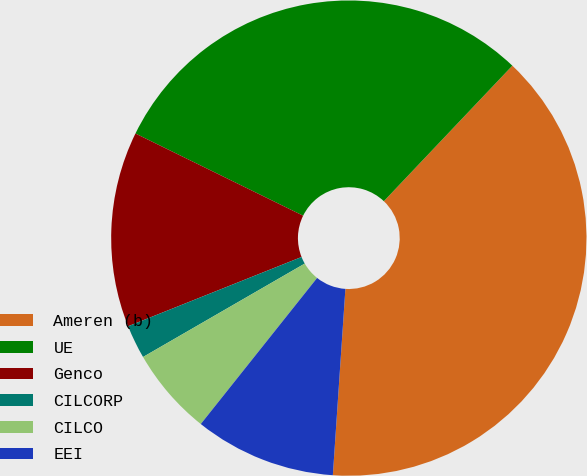<chart> <loc_0><loc_0><loc_500><loc_500><pie_chart><fcel>Ameren (b)<fcel>UE<fcel>Genco<fcel>CILCORP<fcel>CILCO<fcel>EEI<nl><fcel>38.99%<fcel>29.82%<fcel>13.3%<fcel>2.29%<fcel>5.96%<fcel>9.63%<nl></chart> 